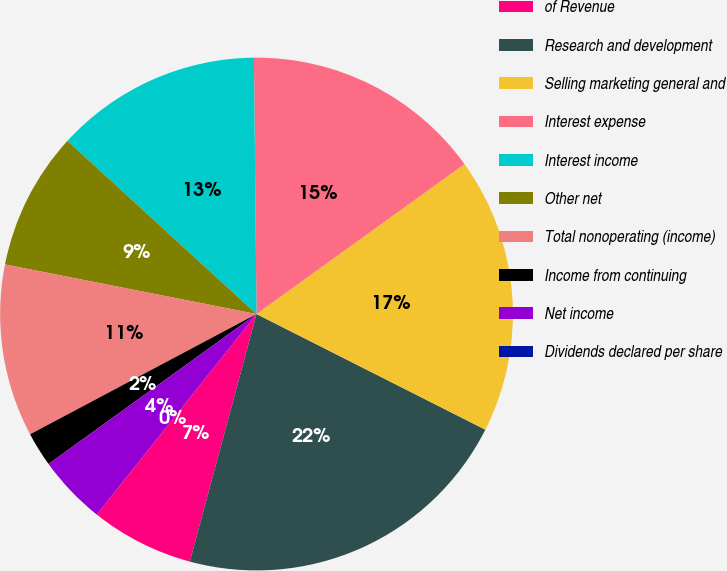Convert chart to OTSL. <chart><loc_0><loc_0><loc_500><loc_500><pie_chart><fcel>of Revenue<fcel>Research and development<fcel>Selling marketing general and<fcel>Interest expense<fcel>Interest income<fcel>Other net<fcel>Total nonoperating (income)<fcel>Income from continuing<fcel>Net income<fcel>Dividends declared per share<nl><fcel>6.52%<fcel>21.74%<fcel>17.39%<fcel>15.22%<fcel>13.04%<fcel>8.7%<fcel>10.87%<fcel>2.17%<fcel>4.35%<fcel>0.0%<nl></chart> 